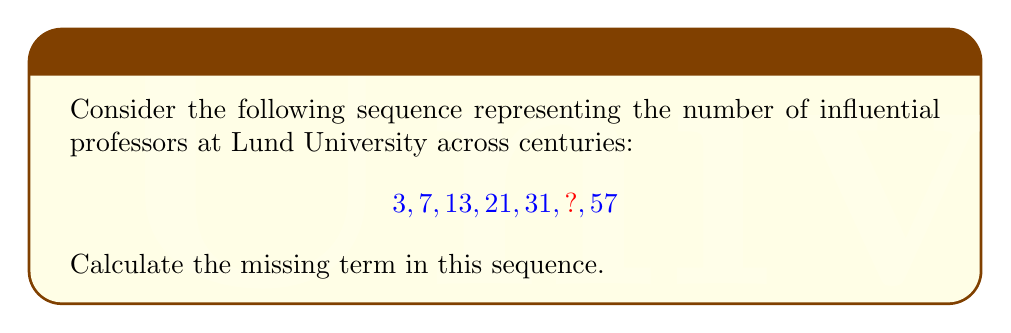Provide a solution to this math problem. To find the missing term, let's analyze the pattern in the sequence:

1) First, calculate the differences between consecutive terms:
   $7 - 3 = 4$
   $13 - 7 = 6$
   $21 - 13 = 8$
   $31 - 21 = 10$
   $57 - ? = ?$

2) We observe that the differences form an arithmetic sequence: 4, 6, 8, 10, ...

3) The pattern in the differences is adding 2 each time: $4 + 2 = 6$, $6 + 2 = 8$, $8 + 2 = 10$, etc.

4) Following this pattern, the next difference should be $10 + 2 = 12$

5) So, to get from 31 to the missing term, we add 12:
   $31 + 12 = 43$

6) We can verify this by checking if $57 - 43 = 14$, which follows the pattern of differences.

Therefore, the missing term in the sequence is 43.
Answer: 43 